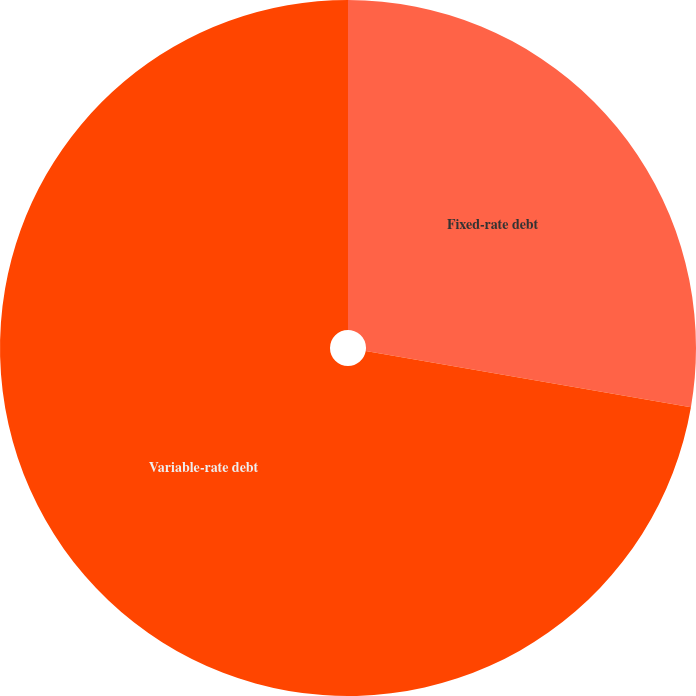<chart> <loc_0><loc_0><loc_500><loc_500><pie_chart><fcel>Fixed-rate debt<fcel>Variable-rate debt<nl><fcel>27.72%<fcel>72.28%<nl></chart> 